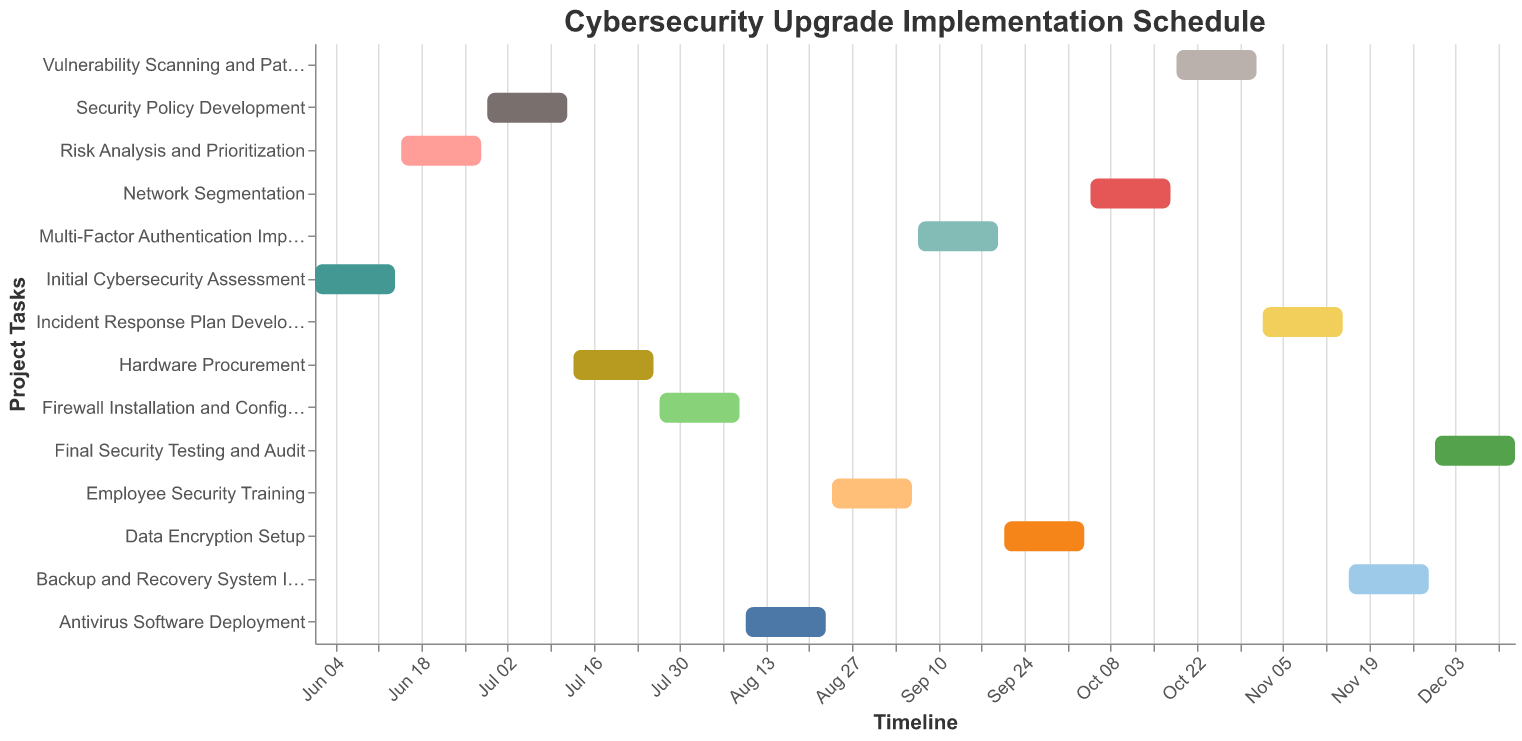What is the duration of the "Risk Analysis and Prioritization" task? Identify the start date and end date for "Risk Analysis and Prioritization" from the figure—a span from June 15 to June 28. The duration is June 28 - June 15 + 1 = 14 days.
Answer: 14 days When does the "Employee Security Training" task start and end? The figure shows that "Employee Security Training" starts on August 24 and ends on September 6.
Answer: August 24 - September 6 Which task starts immediately after the "Firewall Installation and Configuration"? From the figure, the next task following "Firewall Installation and Configuration" (which ends on August 9) is "Antivirus Software Deployment," which starts on August 10.
Answer: Antivirus Software Deployment What is the total number of tasks in the cybersecurity upgrade implementation schedule? Count the number of unique tasks listed on the y-axis in the figure. There are 14 different tasks.
Answer: 14 Which task has the longest duration in the entire schedule? Calculate the duration of each task by subtracting the start date from the end date. The task "Final Security Testing and Audit" runs from November 30 to December 13, which is 14 days, making it the longest task.
Answer: Final Security Testing and Audit How many tasks are scheduled to start in October? From the start dates in the figure, identify tasks beginning in October. The tasks are "Network Segmentation" (October 5) and "Vulnerability Scanning and Patching" (October 19).
Answer: 2 When does the final task, "Final Security Testing and Audit," end? Locate the end date for "Final Security Testing and Audit" in the figure, which is December 13, 2023.
Answer: December 13, 2023 Which two tasks are scheduled for exactly 14 days? Identify tasks with their durations (end date - start date). "Initial Cybersecurity Assessment" (14 days) and "Risk Analysis and Prioritization" (14 days).
Answer: Initial Cybersecurity Assessment and Risk Analysis and Prioritization How long is the gap between the end of "Security Policy Development" and the start of "Hardware Procurement"? The end date for "Security Policy Development" is July 12, and the start date for "Hardware Procurement" is July 13, resulting in no gap.
Answer: No gap Which task is scheduled to start immediately after "Backup and Recovery System Implementation"? From the figure, the task immediately following "Backup and Recovery System Implementation" (ending November 29) is "Final Security Testing and Audit," starting November 30.
Answer: Final Security Testing and Audit 